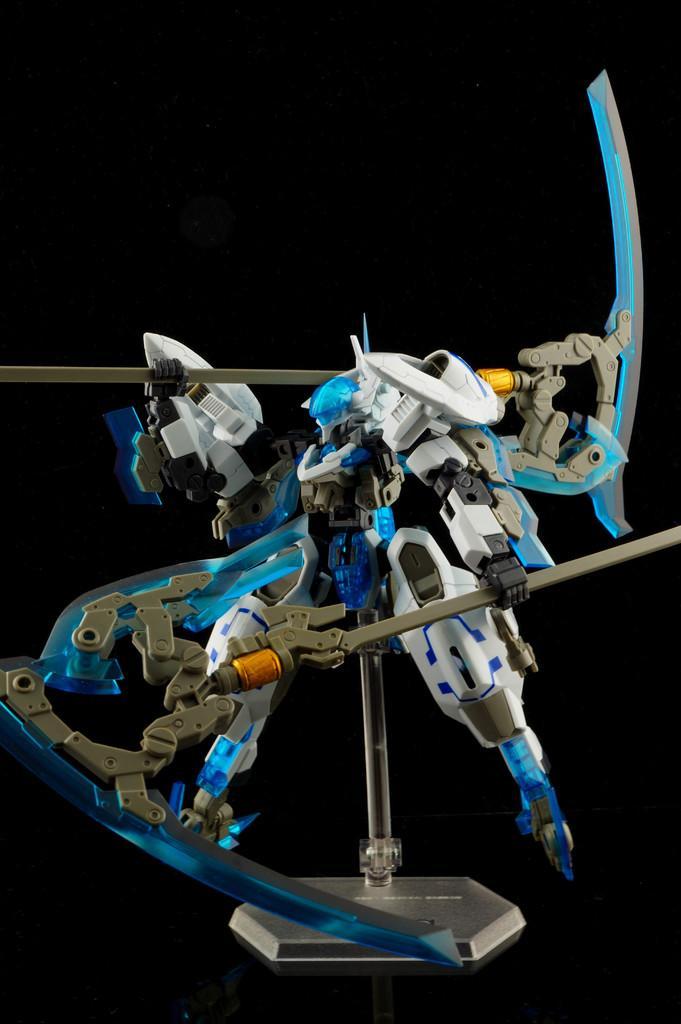How would you summarize this image in a sentence or two? In this image I can see a toy which is blue, white, yellow, orange and grey in color and I can see the black colored background. 